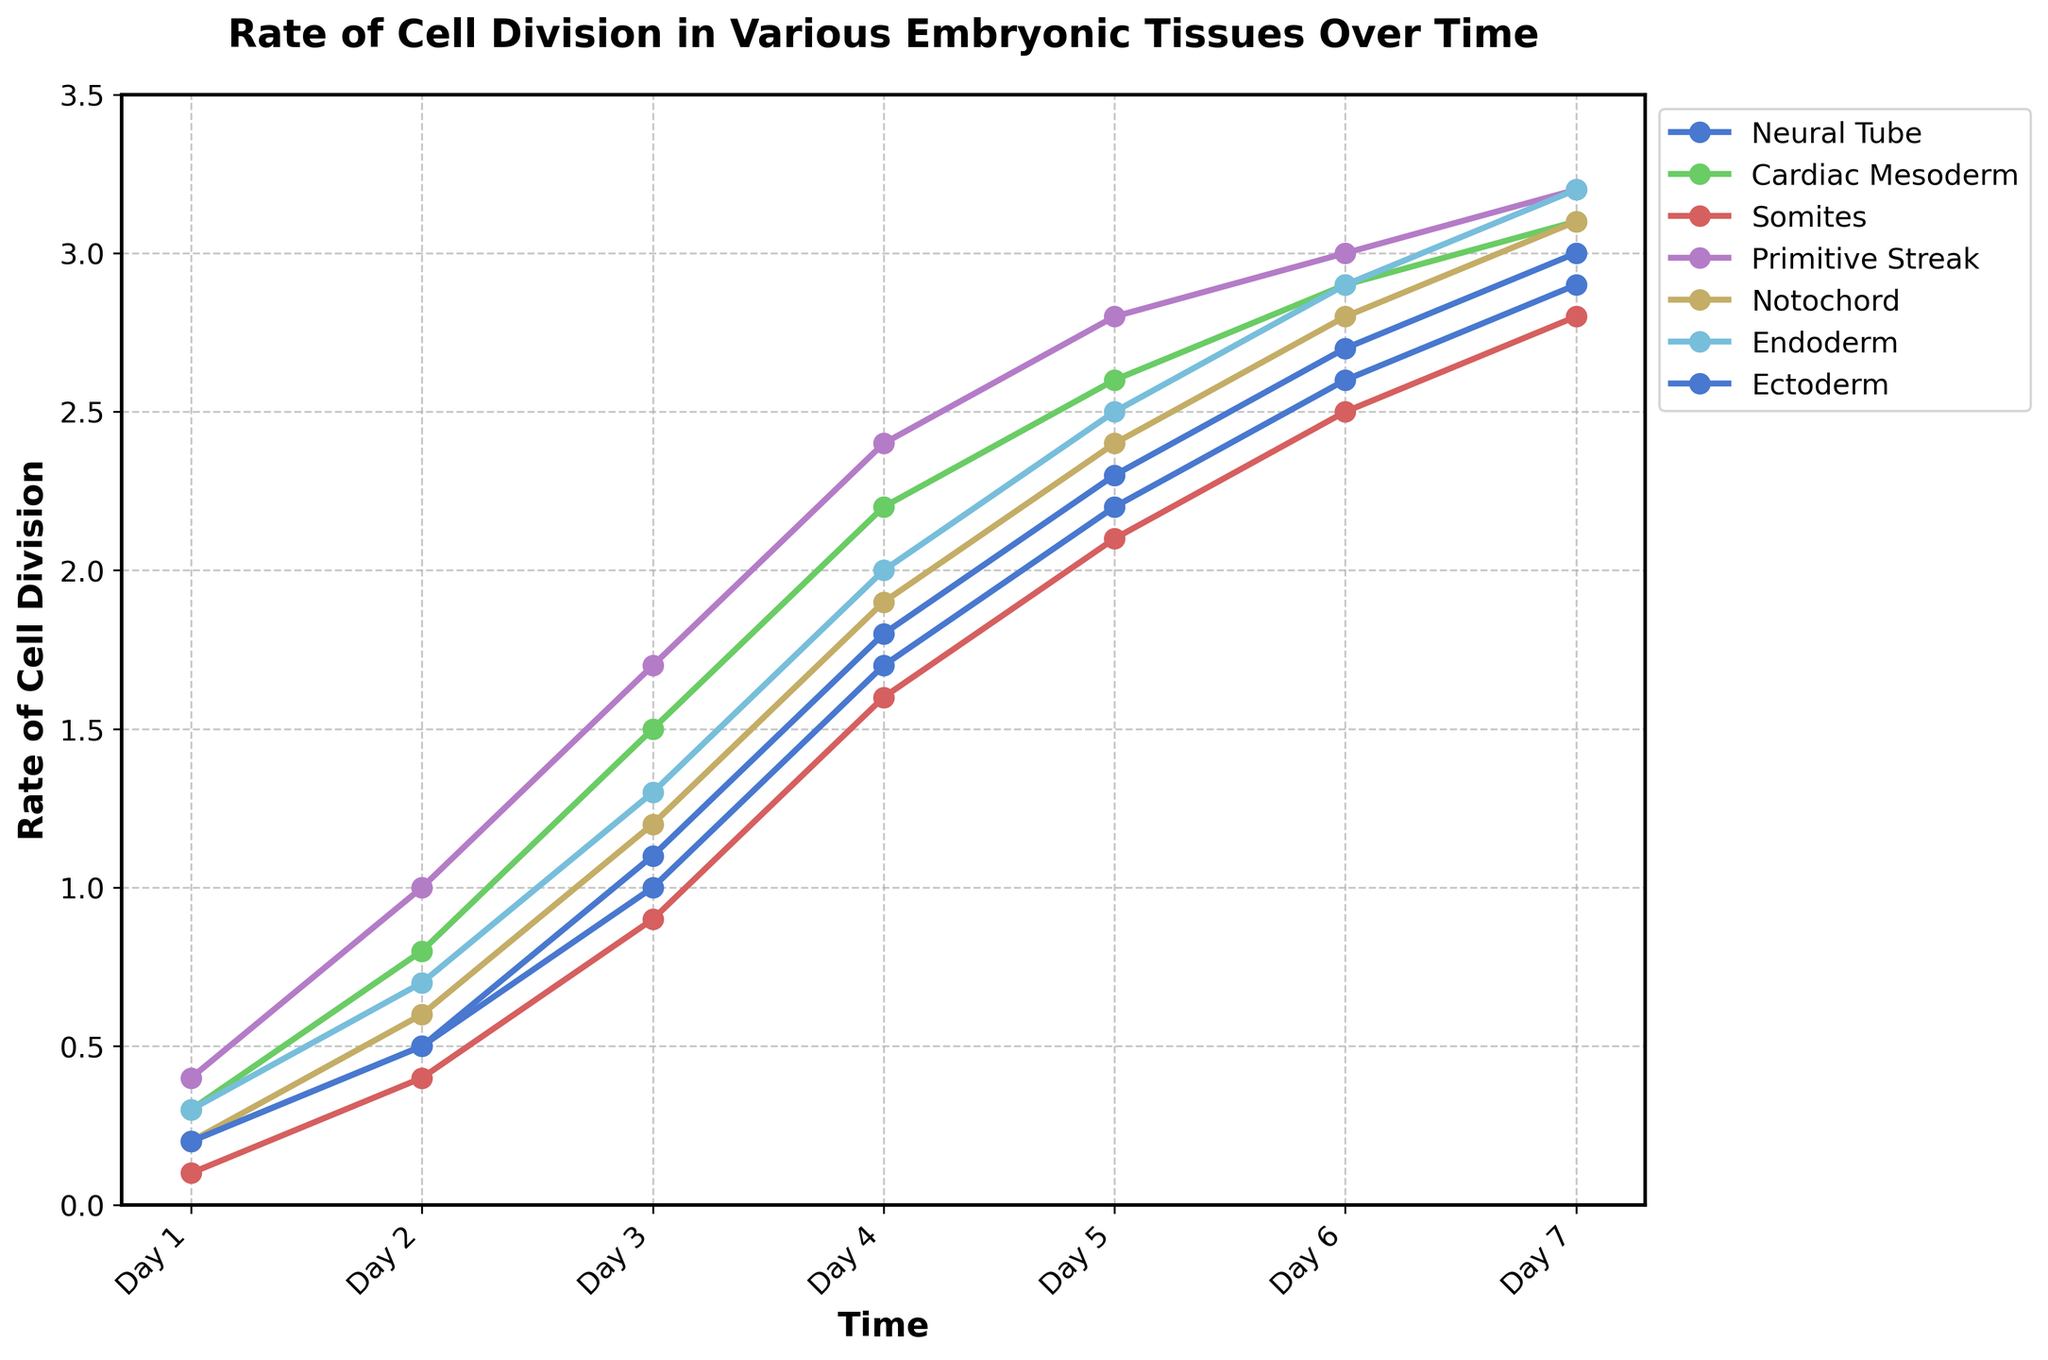What is the rate of cell division in the Notochord tissue on Day 3? Locate the "Notochord" tissue line in the plot and find the data point corresponding to "Day 3". The rate is indicated by the y-axis value at this point.
Answer: 1.2 Which tissue has the highest rate of cell division on Day 5? For Day 5, compare the y-axis values of all tissues and identify the highest. The Primitive Streak and Endoderm both reach a rate of 2.8, which is the highest value for that day.
Answer: Primitive Streak and Endoderm Between which two days does the Neural Tube tissue show the greatest increase in the rate of cell division? Check the rate of cell division for Neural Tube tissue across consecutive days and find the greatest rate change. From Day 2 (0.5) to Day 3 (1.1) is the largest increase of 0.6.
Answer: Day 2 to Day 3 What is the average rate of cell division in the Somites tissue over the 7 days? Sum the daily rates of cell division for Somites from Day 1 to Day 7 and divide by 7 (0.1 + 0.4 + 0.9 + 1.6 + 2.1 + 2.5 + 2.8 = 10.4, then divide by 7).
Answer: 1.49 Which tissue shows the least variability in the rate of cell division over time? Observe each tissue's rate of cell division and determine the one with the smallest range from minimum to maximum values. The Endoderm varies from 0.3 to 3.2, the smallest range is for the Neural Tube, varying from 0.2 to 3.0.
Answer: Neural Tube On which day does the Cardiac Mesoderm tissue surpass a rate of cell division of 2.0? Follow the Cardiac Mesoderm line and find the first day the rate is above 2.0. That occurs on Day 4 (2.2).
Answer: Day 4 Compare the rates of cell division for Neural Tube and Ectoderm on Day 6. Which is higher? Check the rates of cell division on Day 6 for both Neural Tube and Ectoderm on the y-axis. Neural Tube shows 2.7, while Ectoderm shows 2.6.
Answer: Neural Tube 